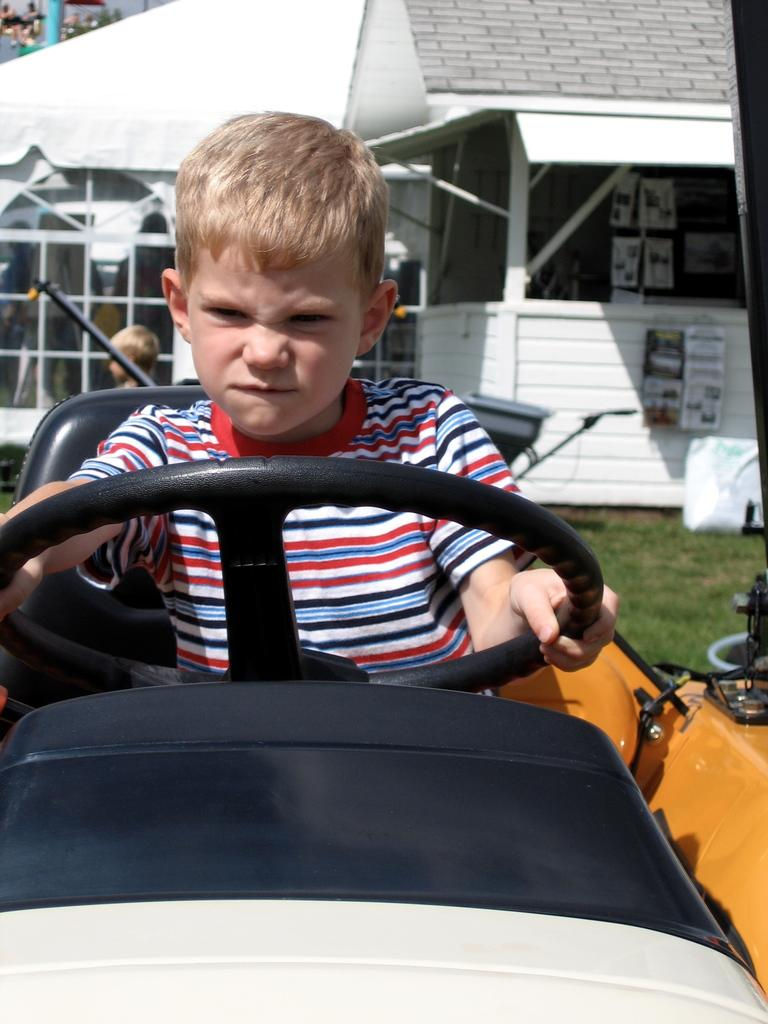What is the kid doing in the image? The kid is sitting on a vehicle in the image. What can be seen in the background of the image? There is a building in the background of the image. Are there any other kids visible in the image? Yes, there is another kid on the left side of the image. What type of unit is being used to measure the reaction of the system in the image? There is no mention of any unit, reaction, or system in the image; it simply shows a kid sitting on a vehicle and another kid on the left side of the image. 